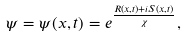Convert formula to latex. <formula><loc_0><loc_0><loc_500><loc_500>\psi = \psi ( x , t ) = e ^ { \frac { R ( x , t ) + i S ( x , t ) } { \chi } } ,</formula> 